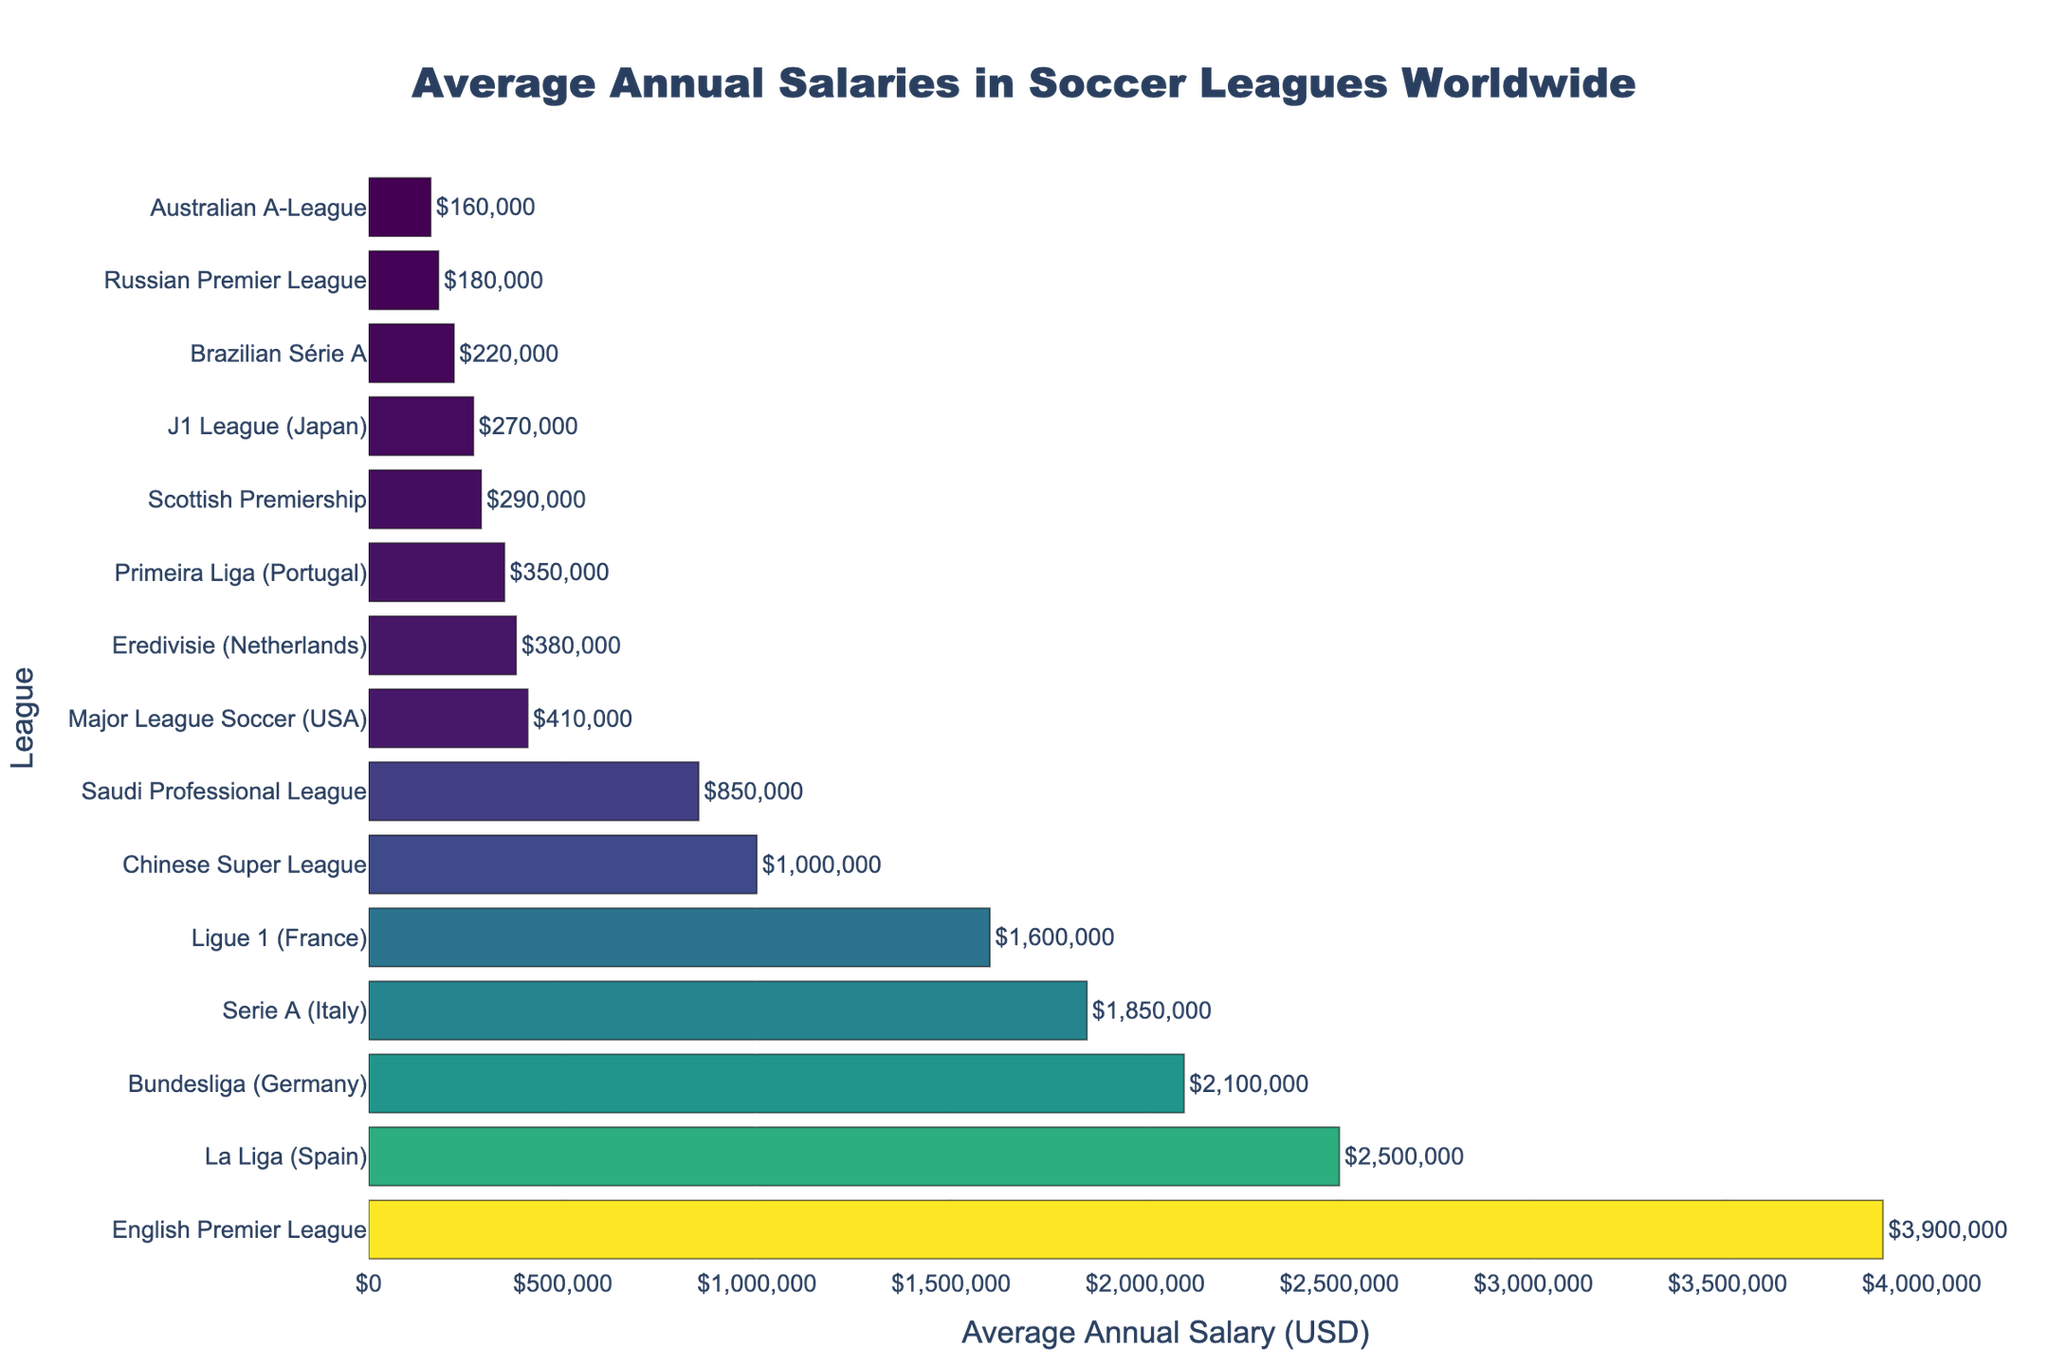Which league has the highest average annual salary? The league with the highest average annual salary is the one with the top-most bar in the bar chart. In this case, it is the English Premier League.
Answer: English Premier League Which league has the lowest average annual salary? The league with the lowest average annual salary is the one with the shortest bar at the bottom of the chart. In this case, it is the Brazilian Série A.
Answer: Brazilian Série A How much higher is the average annual salary in the English Premier League compared to Major League Soccer? The English Premier League has an average annual salary of 3,900,000 USD, while Major League Soccer has 410,000 USD. The difference is calculated by subtracting the smaller amount from the larger amount: 3,900,000 - 410,000 = 3,490,000 USD.
Answer: 3,490,000 USD Which leagues have average annual salaries greater than 2,000,000 USD? By observing the bars greater than 2,000,000 USD in height, we can identify the leagues. These are the English Premier League, La Liga (Spain), and Bundesliga (Germany).
Answer: English Premier League, La Liga (Spain), Bundesliga (Germany) What is the average annual salary range (difference between the highest and lowest) among the leagues? The range is calculated by subtracting the lowest average annual salary from the highest. The highest is 3,900,000 USD (English Premier League) and the lowest is 220,000 USD (Brazilian Série A). Thus, 3,900,000 - 220,000 = 3,680,000 USD.
Answer: 3,680,000 USD Is the average salary in the Serie A (Italy) higher or lower than in the Ligue 1 (France), and by how much? Serie A has an average annual salary of 1,850,000 USD, while Ligue 1 has 1,600,000 USD. The difference is 1,850,000 - 1,600,000 = 250,000 USD. Since 1,850,000 USD is greater, Serie A is higher by 250,000 USD.
Answer: Higher by 250,000 USD What is the combined average annual salary for the leagues from Scotland, Japan, and Russia? The respective average salaries are 290,000 USD (Scottish Premiership), 270,000 USD (J1 League), and 180,000 USD (Russian Premier League). The combined salary is 290,000 + 270,000 + 180,000 = 740,000 USD.
Answer: 740,000 USD What is the ratio of the highest average salary to the lowest average salary? The highest average salary is 3,900,000 USD (English Premier League) and the lowest is 220,000 USD (Brazilian Série A). The ratio is 3,900,000 / 220,000 = 17.73.
Answer: 17.73 Which league has an average annual salary closest to 1,000,000 USD? The league with the average annual salary closest to 1,000,000 USD is the Chinese Super League, which has an average of exactly 1,000,000 USD.
Answer: Chinese Super League 